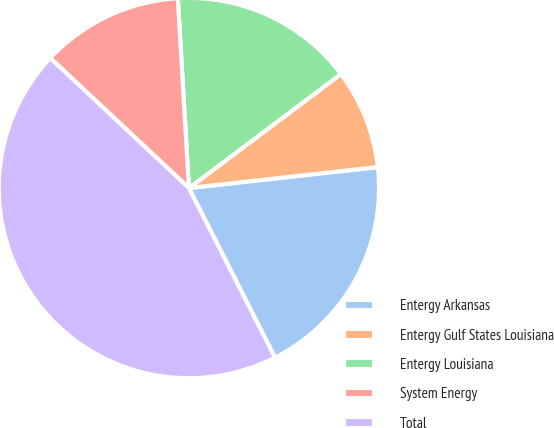Convert chart to OTSL. <chart><loc_0><loc_0><loc_500><loc_500><pie_chart><fcel>Entergy Arkansas<fcel>Entergy Gulf States Louisiana<fcel>Entergy Louisiana<fcel>System Energy<fcel>Total<nl><fcel>19.28%<fcel>8.49%<fcel>15.68%<fcel>12.08%<fcel>44.47%<nl></chart> 